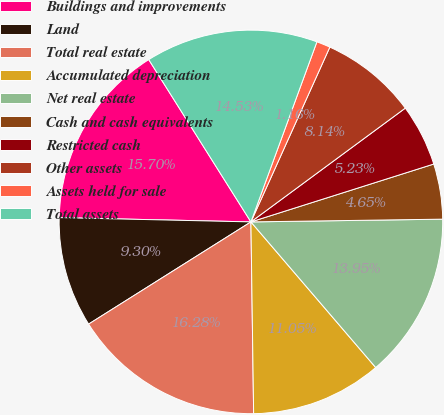<chart> <loc_0><loc_0><loc_500><loc_500><pie_chart><fcel>Buildings and improvements<fcel>Land<fcel>Total real estate<fcel>Accumulated depreciation<fcel>Net real estate<fcel>Cash and cash equivalents<fcel>Restricted cash<fcel>Other assets<fcel>Assets held for sale<fcel>Total assets<nl><fcel>15.7%<fcel>9.3%<fcel>16.28%<fcel>11.05%<fcel>13.95%<fcel>4.65%<fcel>5.23%<fcel>8.14%<fcel>1.16%<fcel>14.53%<nl></chart> 